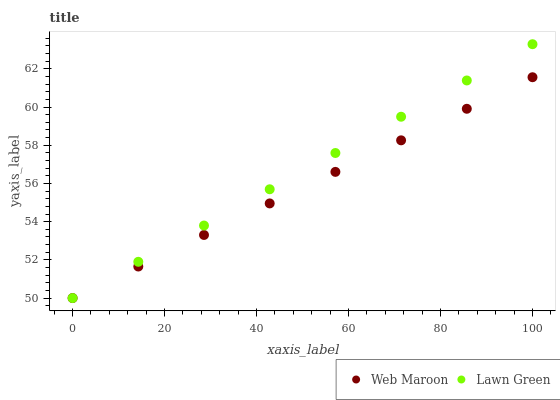Does Web Maroon have the minimum area under the curve?
Answer yes or no. Yes. Does Lawn Green have the maximum area under the curve?
Answer yes or no. Yes. Does Web Maroon have the maximum area under the curve?
Answer yes or no. No. Is Lawn Green the smoothest?
Answer yes or no. Yes. Is Web Maroon the roughest?
Answer yes or no. Yes. Is Web Maroon the smoothest?
Answer yes or no. No. Does Lawn Green have the lowest value?
Answer yes or no. Yes. Does Lawn Green have the highest value?
Answer yes or no. Yes. Does Web Maroon have the highest value?
Answer yes or no. No. Does Web Maroon intersect Lawn Green?
Answer yes or no. Yes. Is Web Maroon less than Lawn Green?
Answer yes or no. No. Is Web Maroon greater than Lawn Green?
Answer yes or no. No. 